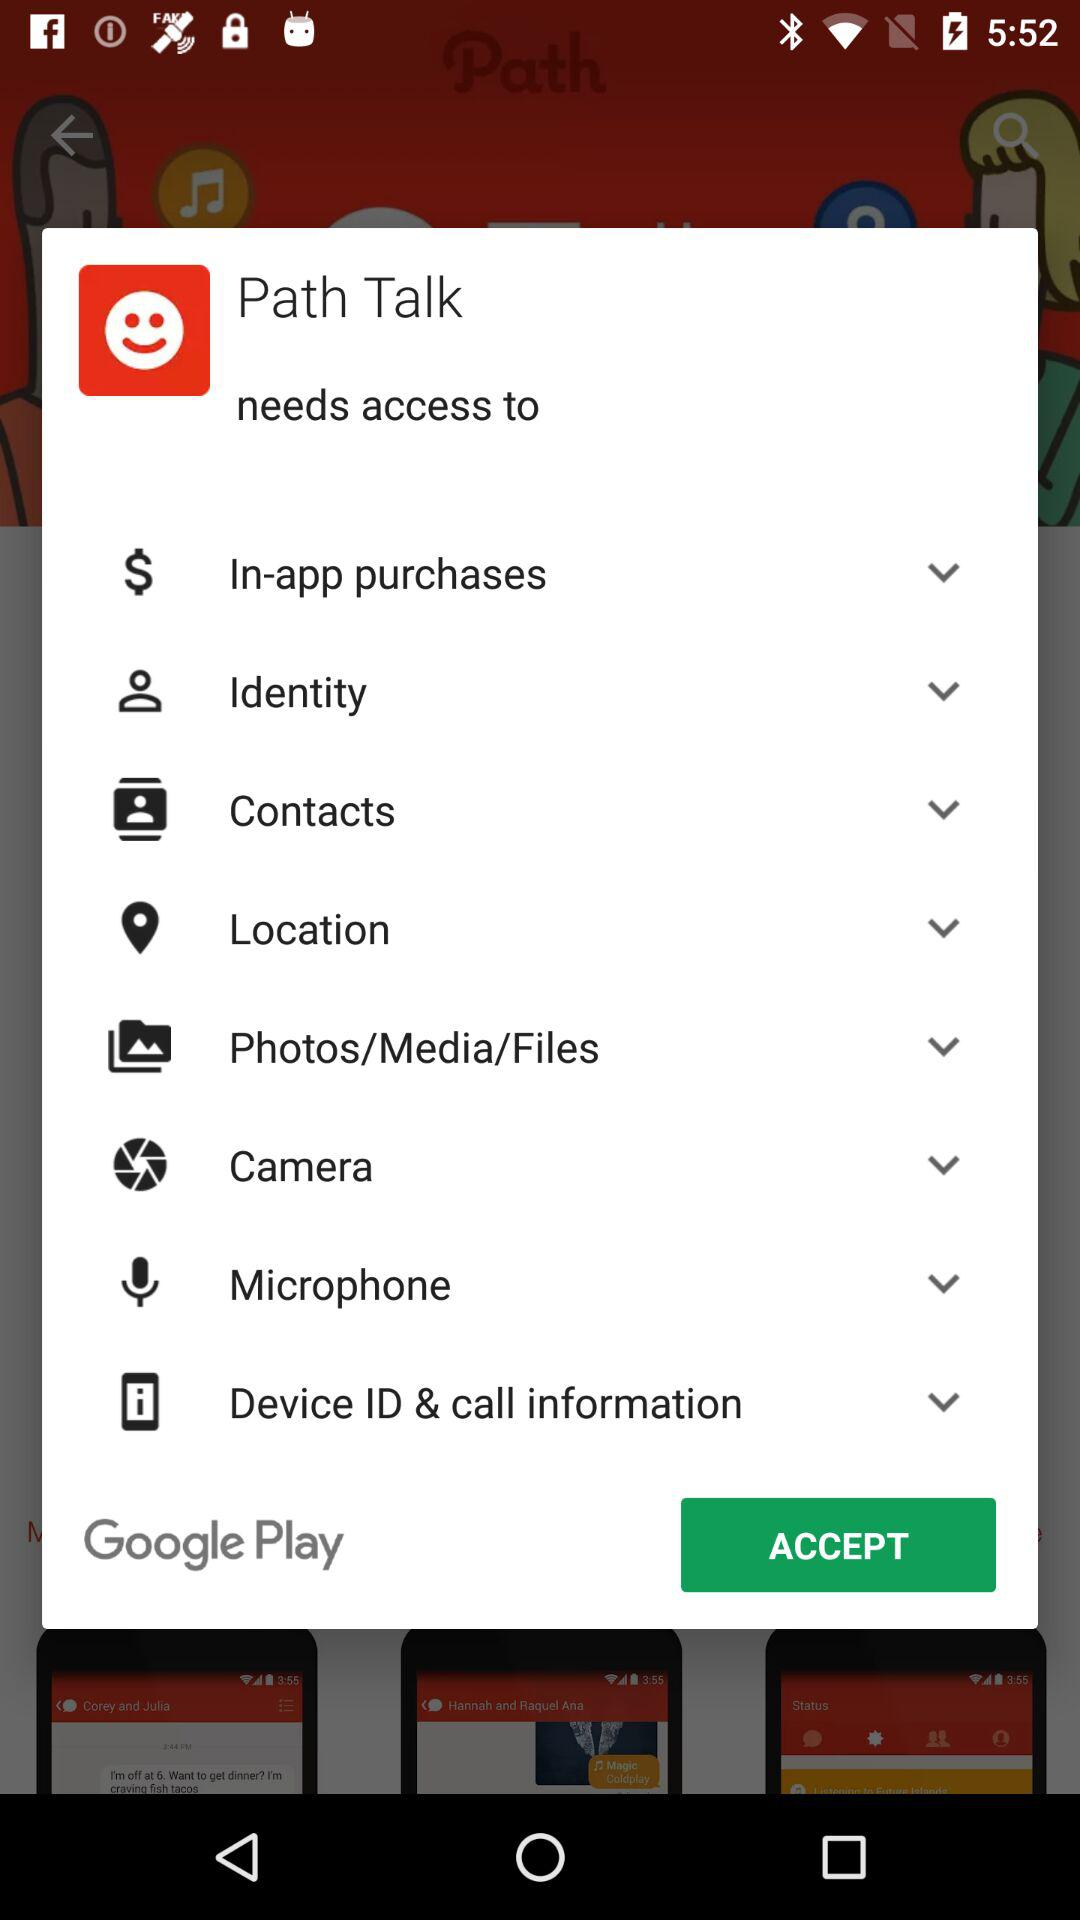What is the name of the application? The name of the application is Path Talk. 